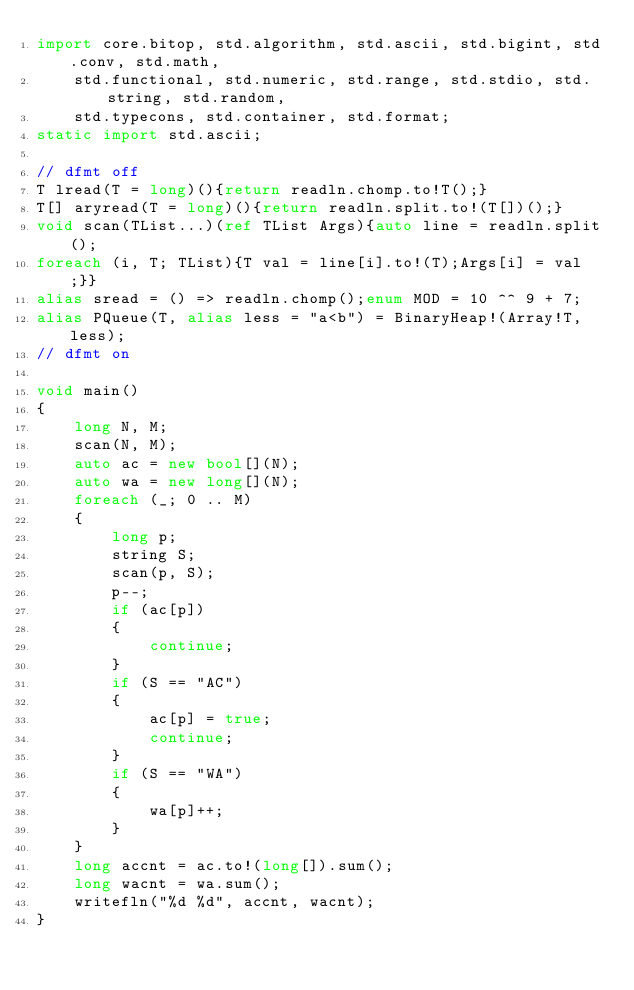<code> <loc_0><loc_0><loc_500><loc_500><_D_>import core.bitop, std.algorithm, std.ascii, std.bigint, std.conv, std.math,
    std.functional, std.numeric, std.range, std.stdio, std.string, std.random,
    std.typecons, std.container, std.format;
static import std.ascii;

// dfmt off
T lread(T = long)(){return readln.chomp.to!T();}
T[] aryread(T = long)(){return readln.split.to!(T[])();}
void scan(TList...)(ref TList Args){auto line = readln.split();
foreach (i, T; TList){T val = line[i].to!(T);Args[i] = val;}}
alias sread = () => readln.chomp();enum MOD = 10 ^^ 9 + 7;
alias PQueue(T, alias less = "a<b") = BinaryHeap!(Array!T, less);
// dfmt on

void main()
{
    long N, M;
    scan(N, M);
    auto ac = new bool[](N);
    auto wa = new long[](N);
    foreach (_; 0 .. M)
    {
        long p;
        string S;
        scan(p, S);
        p--;
        if (ac[p])
        {
            continue;
        }
        if (S == "AC")
        {
            ac[p] = true;
            continue;
        }
        if (S == "WA")
        {
            wa[p]++;
        }
    }
    long accnt = ac.to!(long[]).sum();
    long wacnt = wa.sum();
    writefln("%d %d", accnt, wacnt);
}
</code> 